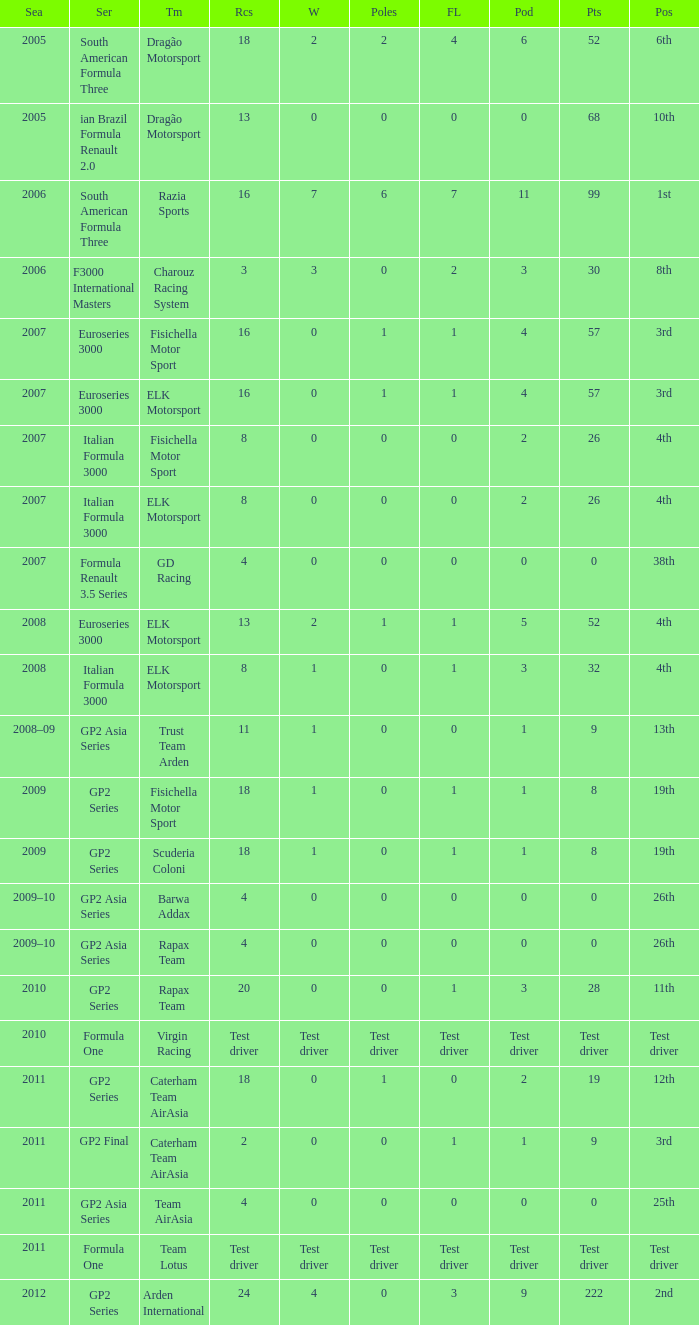How many races did he do in the year he had 8 points? 18, 18. 